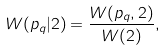Convert formula to latex. <formula><loc_0><loc_0><loc_500><loc_500>W ( p _ { q } | 2 ) = \frac { W ( p _ { q } , 2 ) } { W ( 2 ) } ,</formula> 